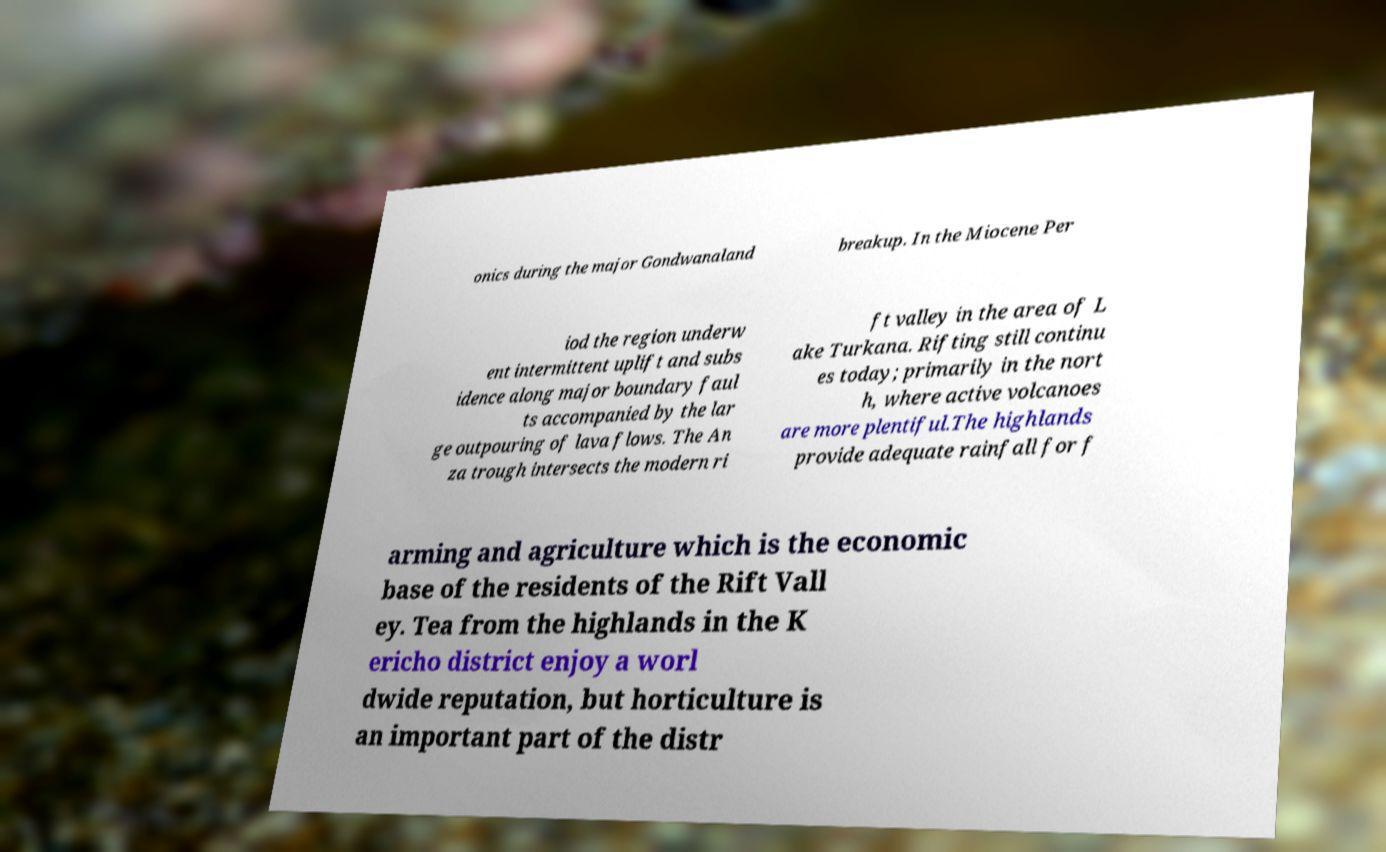There's text embedded in this image that I need extracted. Can you transcribe it verbatim? onics during the major Gondwanaland breakup. In the Miocene Per iod the region underw ent intermittent uplift and subs idence along major boundary faul ts accompanied by the lar ge outpouring of lava flows. The An za trough intersects the modern ri ft valley in the area of L ake Turkana. Rifting still continu es today; primarily in the nort h, where active volcanoes are more plentiful.The highlands provide adequate rainfall for f arming and agriculture which is the economic base of the residents of the Rift Vall ey. Tea from the highlands in the K ericho district enjoy a worl dwide reputation, but horticulture is an important part of the distr 